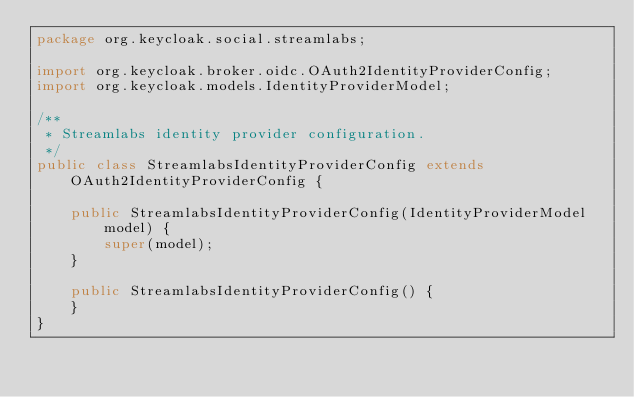<code> <loc_0><loc_0><loc_500><loc_500><_Java_>package org.keycloak.social.streamlabs;

import org.keycloak.broker.oidc.OAuth2IdentityProviderConfig;
import org.keycloak.models.IdentityProviderModel;

/**
 * Streamlabs identity provider configuration.
 */
public class StreamlabsIdentityProviderConfig extends OAuth2IdentityProviderConfig {

    public StreamlabsIdentityProviderConfig(IdentityProviderModel model) {
        super(model);
    }

    public StreamlabsIdentityProviderConfig() {
    }
}
</code> 